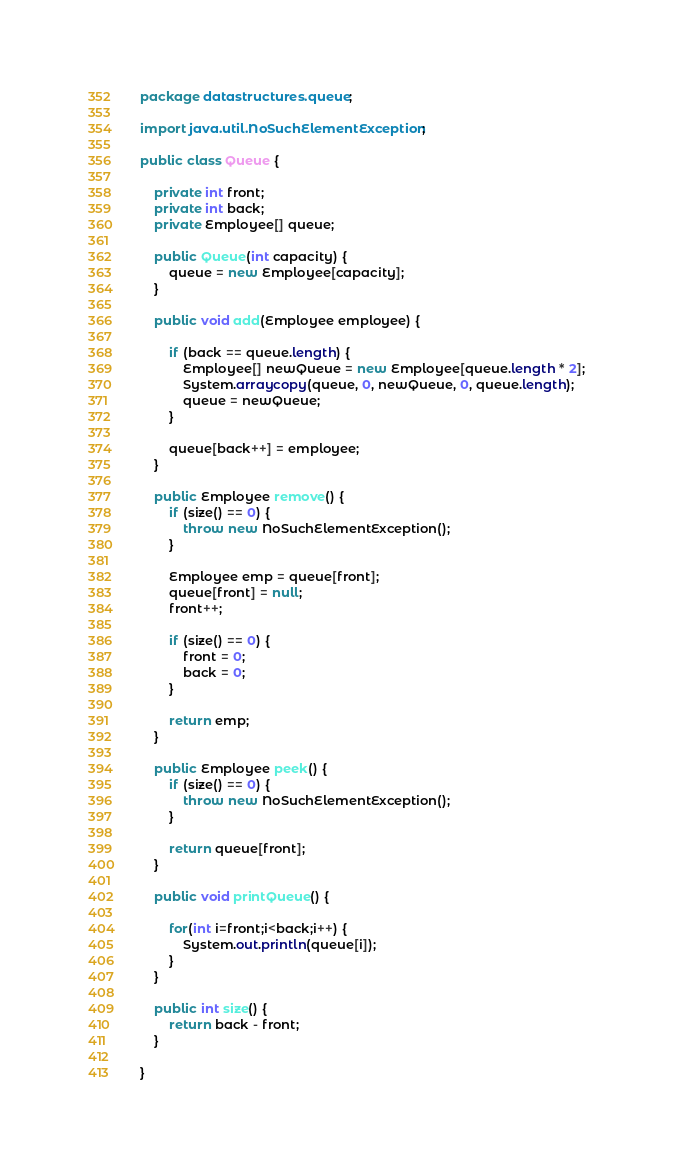<code> <loc_0><loc_0><loc_500><loc_500><_Java_>package datastructures.queue;

import java.util.NoSuchElementException;

public class Queue {

	private int front;
	private int back;
	private Employee[] queue;

	public Queue(int capacity) {
		queue = new Employee[capacity];
	}

	public void add(Employee employee) {

		if (back == queue.length) {
			Employee[] newQueue = new Employee[queue.length * 2];
			System.arraycopy(queue, 0, newQueue, 0, queue.length);
			queue = newQueue;
		}

		queue[back++] = employee;
	}

	public Employee remove() {
		if (size() == 0) {
			throw new NoSuchElementException();
		}

		Employee emp = queue[front];
		queue[front] = null;
		front++;

		if (size() == 0) {
			front = 0;
			back = 0;
		}

		return emp;
	}

	public Employee peek() {
		if (size() == 0) {
			throw new NoSuchElementException();
		}

		return queue[front];
	}
	
	public void printQueue() {
		
		for(int i=front;i<back;i++) {
			System.out.println(queue[i]);
		}
	}

	public int size() {
		return back - front;
	}

}
</code> 